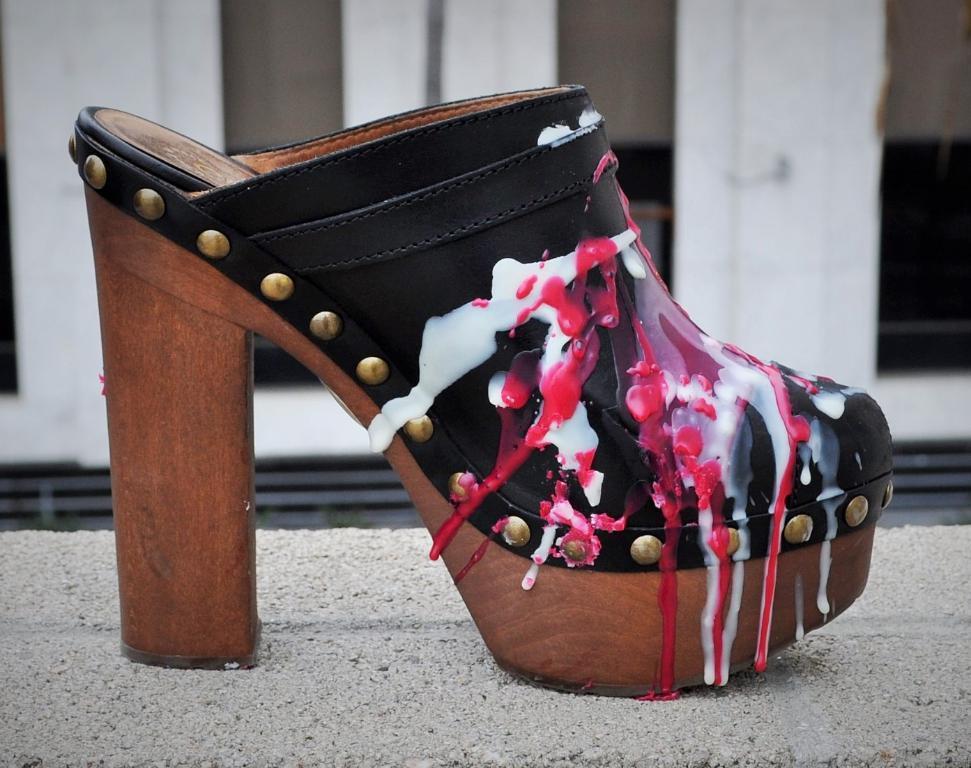How would you summarize this image in a sentence or two? In this image we can see a slipper on the floor. 